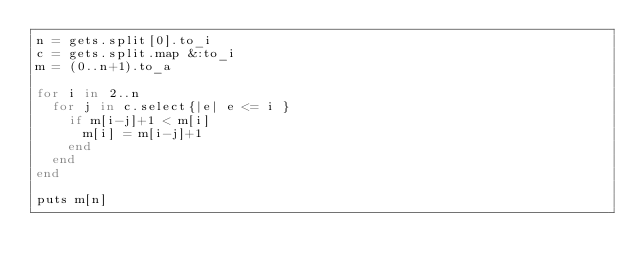<code> <loc_0><loc_0><loc_500><loc_500><_Ruby_>n = gets.split[0].to_i
c = gets.split.map &:to_i
m = (0..n+1).to_a

for i in 2..n
  for j in c.select{|e| e <= i }
    if m[i-j]+1 < m[i]
      m[i] = m[i-j]+1
    end
  end
end

puts m[n]</code> 